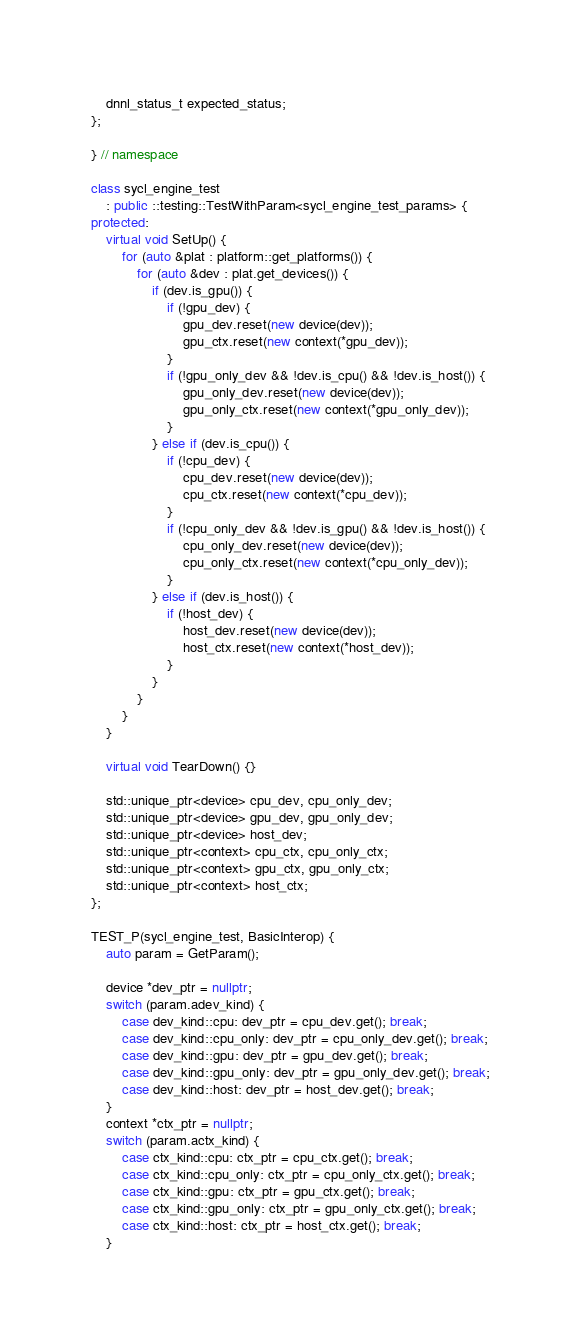<code> <loc_0><loc_0><loc_500><loc_500><_C++_>    dnnl_status_t expected_status;
};

} // namespace

class sycl_engine_test
    : public ::testing::TestWithParam<sycl_engine_test_params> {
protected:
    virtual void SetUp() {
        for (auto &plat : platform::get_platforms()) {
            for (auto &dev : plat.get_devices()) {
                if (dev.is_gpu()) {
                    if (!gpu_dev) {
                        gpu_dev.reset(new device(dev));
                        gpu_ctx.reset(new context(*gpu_dev));
                    }
                    if (!gpu_only_dev && !dev.is_cpu() && !dev.is_host()) {
                        gpu_only_dev.reset(new device(dev));
                        gpu_only_ctx.reset(new context(*gpu_only_dev));
                    }
                } else if (dev.is_cpu()) {
                    if (!cpu_dev) {
                        cpu_dev.reset(new device(dev));
                        cpu_ctx.reset(new context(*cpu_dev));
                    }
                    if (!cpu_only_dev && !dev.is_gpu() && !dev.is_host()) {
                        cpu_only_dev.reset(new device(dev));
                        cpu_only_ctx.reset(new context(*cpu_only_dev));
                    }
                } else if (dev.is_host()) {
                    if (!host_dev) {
                        host_dev.reset(new device(dev));
                        host_ctx.reset(new context(*host_dev));
                    }
                }
            }
        }
    }

    virtual void TearDown() {}

    std::unique_ptr<device> cpu_dev, cpu_only_dev;
    std::unique_ptr<device> gpu_dev, gpu_only_dev;
    std::unique_ptr<device> host_dev;
    std::unique_ptr<context> cpu_ctx, cpu_only_ctx;
    std::unique_ptr<context> gpu_ctx, gpu_only_ctx;
    std::unique_ptr<context> host_ctx;
};

TEST_P(sycl_engine_test, BasicInterop) {
    auto param = GetParam();

    device *dev_ptr = nullptr;
    switch (param.adev_kind) {
        case dev_kind::cpu: dev_ptr = cpu_dev.get(); break;
        case dev_kind::cpu_only: dev_ptr = cpu_only_dev.get(); break;
        case dev_kind::gpu: dev_ptr = gpu_dev.get(); break;
        case dev_kind::gpu_only: dev_ptr = gpu_only_dev.get(); break;
        case dev_kind::host: dev_ptr = host_dev.get(); break;
    }
    context *ctx_ptr = nullptr;
    switch (param.actx_kind) {
        case ctx_kind::cpu: ctx_ptr = cpu_ctx.get(); break;
        case ctx_kind::cpu_only: ctx_ptr = cpu_only_ctx.get(); break;
        case ctx_kind::gpu: ctx_ptr = gpu_ctx.get(); break;
        case ctx_kind::gpu_only: ctx_ptr = gpu_only_ctx.get(); break;
        case ctx_kind::host: ctx_ptr = host_ctx.get(); break;
    }
</code> 